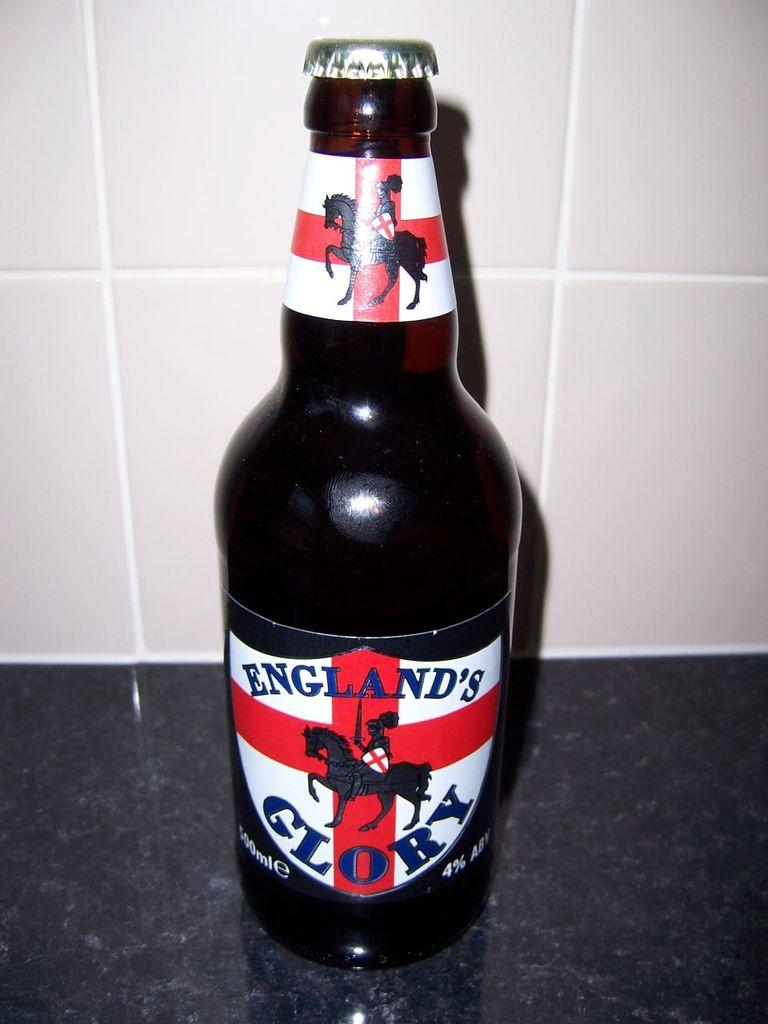<image>
Render a clear and concise summary of the photo. A black bottle that is by a brand called England's Glory. 